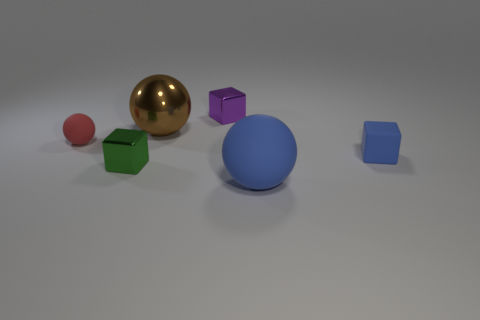Subtract all large balls. How many balls are left? 1 Add 3 tiny red balls. How many objects exist? 9 Add 2 tiny blue matte objects. How many tiny blue matte objects exist? 3 Subtract 0 yellow balls. How many objects are left? 6 Subtract all large blue matte things. Subtract all cyan cubes. How many objects are left? 5 Add 1 purple shiny objects. How many purple shiny objects are left? 2 